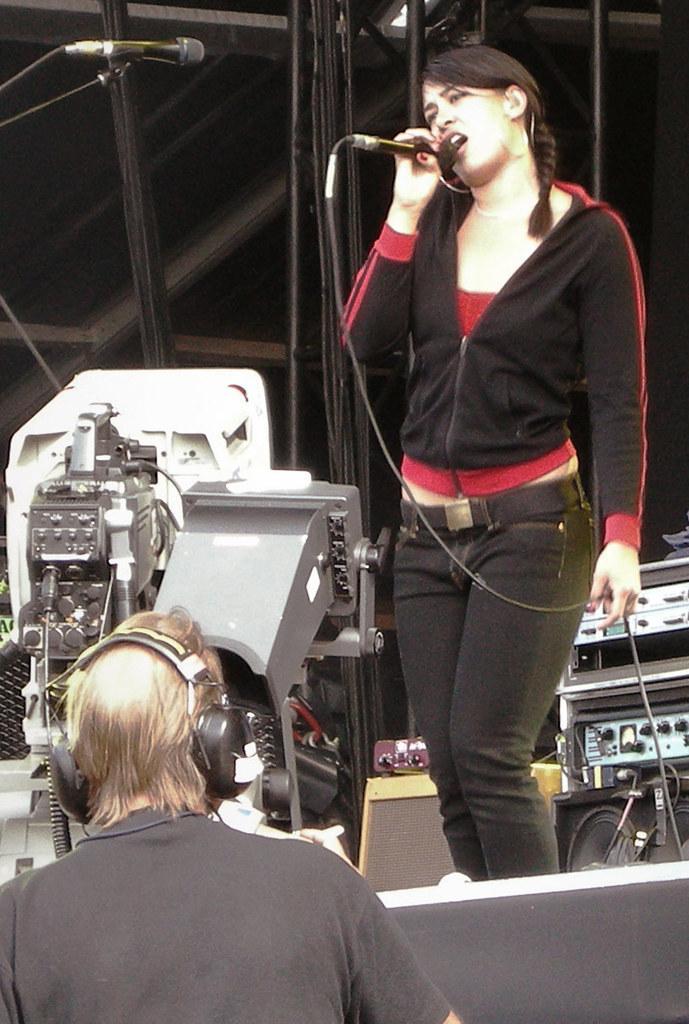How would you summarize this image in a sentence or two? In this image, on the right there is a woman she wear black jacket, belt and trouser her hair is short, she is singing. At the bottom there is a person. In the back ground there are speakers, camera, mic and some other things. I think this is a stage performance. 